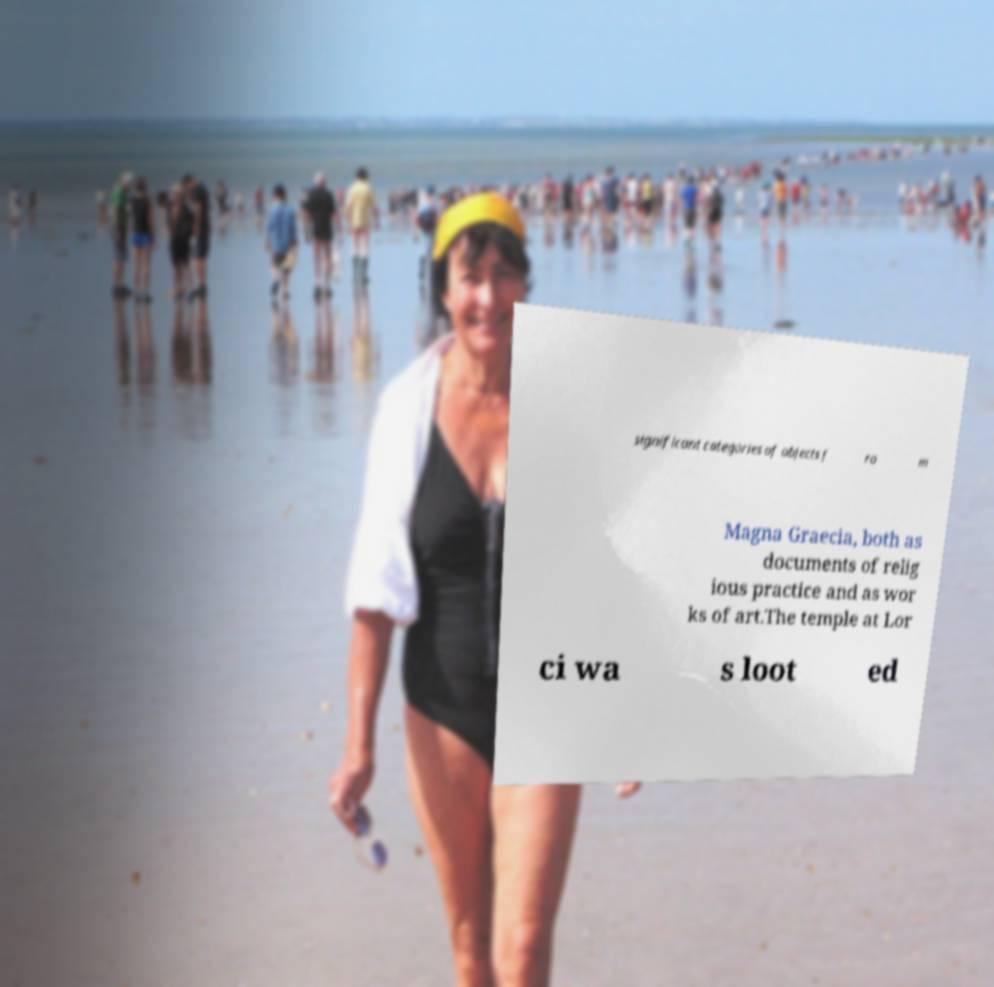Can you accurately transcribe the text from the provided image for me? significant categories of objects f ro m Magna Graecia, both as documents of relig ious practice and as wor ks of art.The temple at Lor ci wa s loot ed 